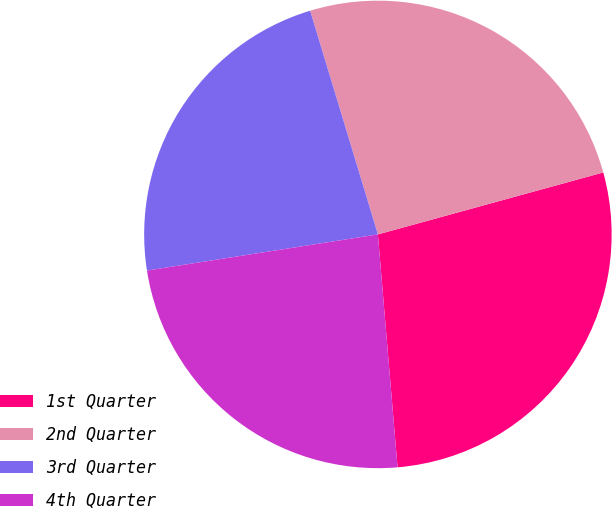Convert chart. <chart><loc_0><loc_0><loc_500><loc_500><pie_chart><fcel>1st Quarter<fcel>2nd Quarter<fcel>3rd Quarter<fcel>4th Quarter<nl><fcel>27.93%<fcel>25.41%<fcel>22.79%<fcel>23.87%<nl></chart> 